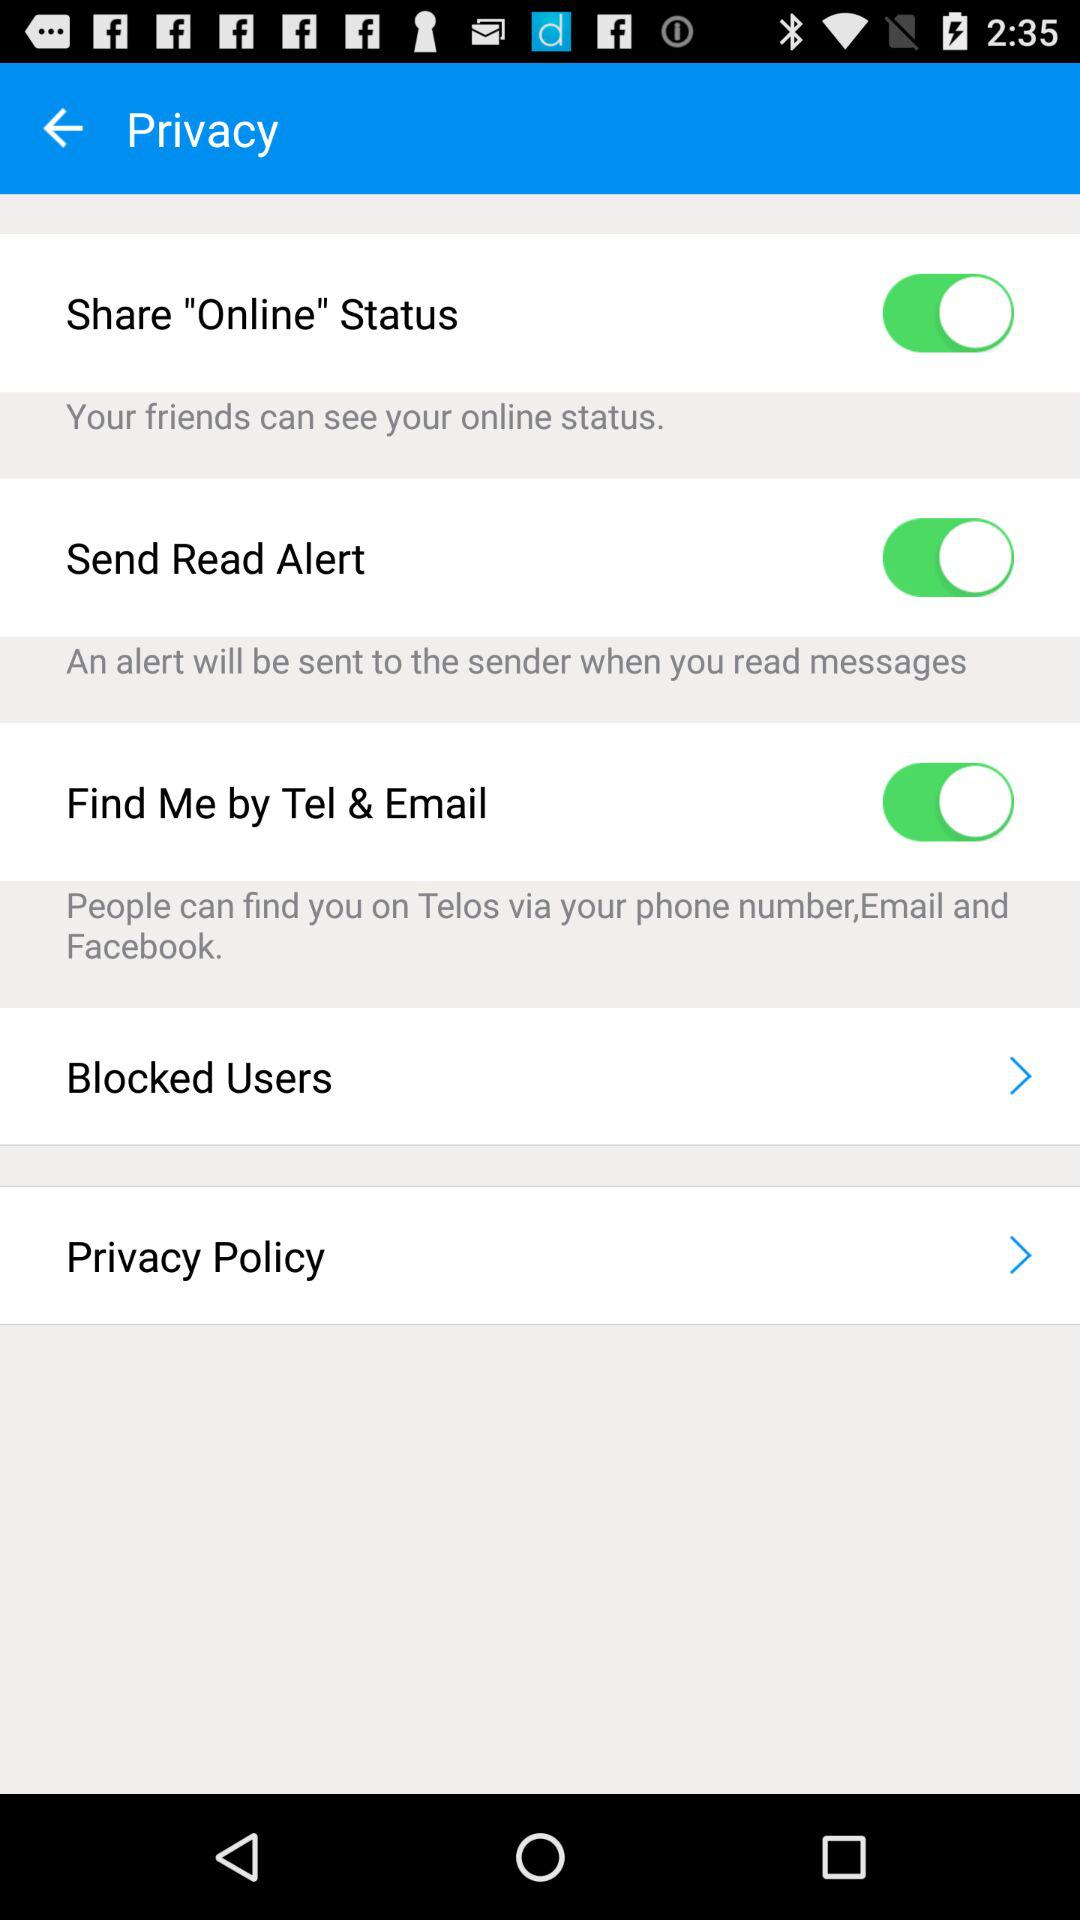Who can see my online status? Your friends can see your online status. 